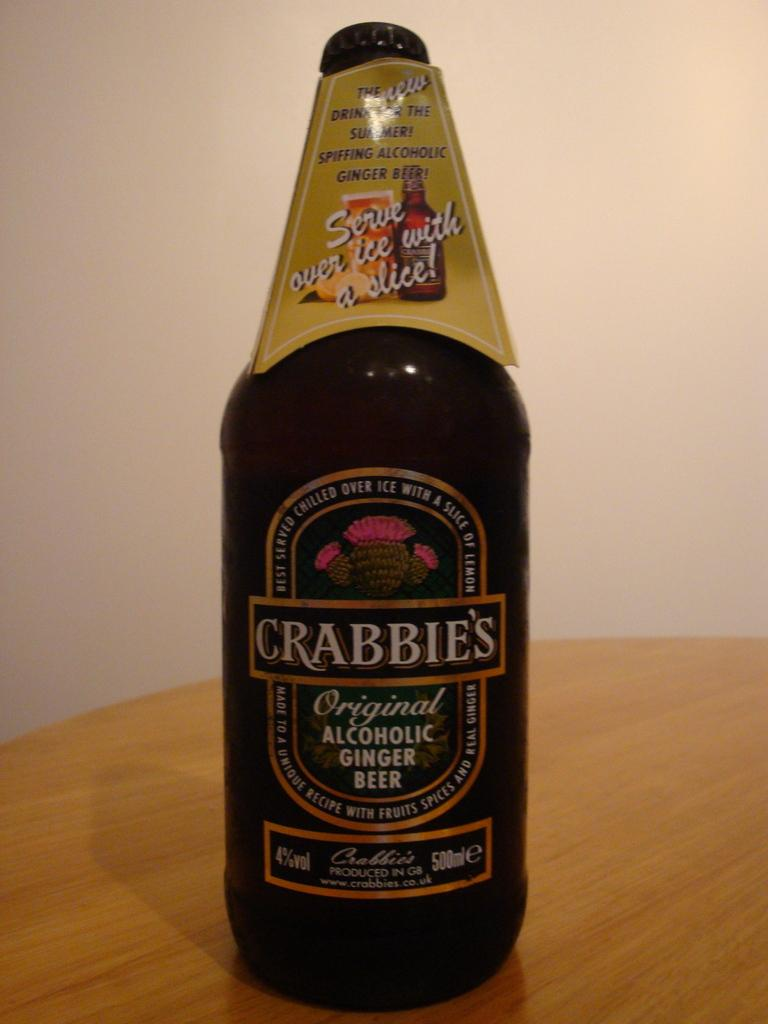<image>
Render a clear and concise summary of the photo. A bottle of Crabbie's Original Alcoholic Ginger Beer. 